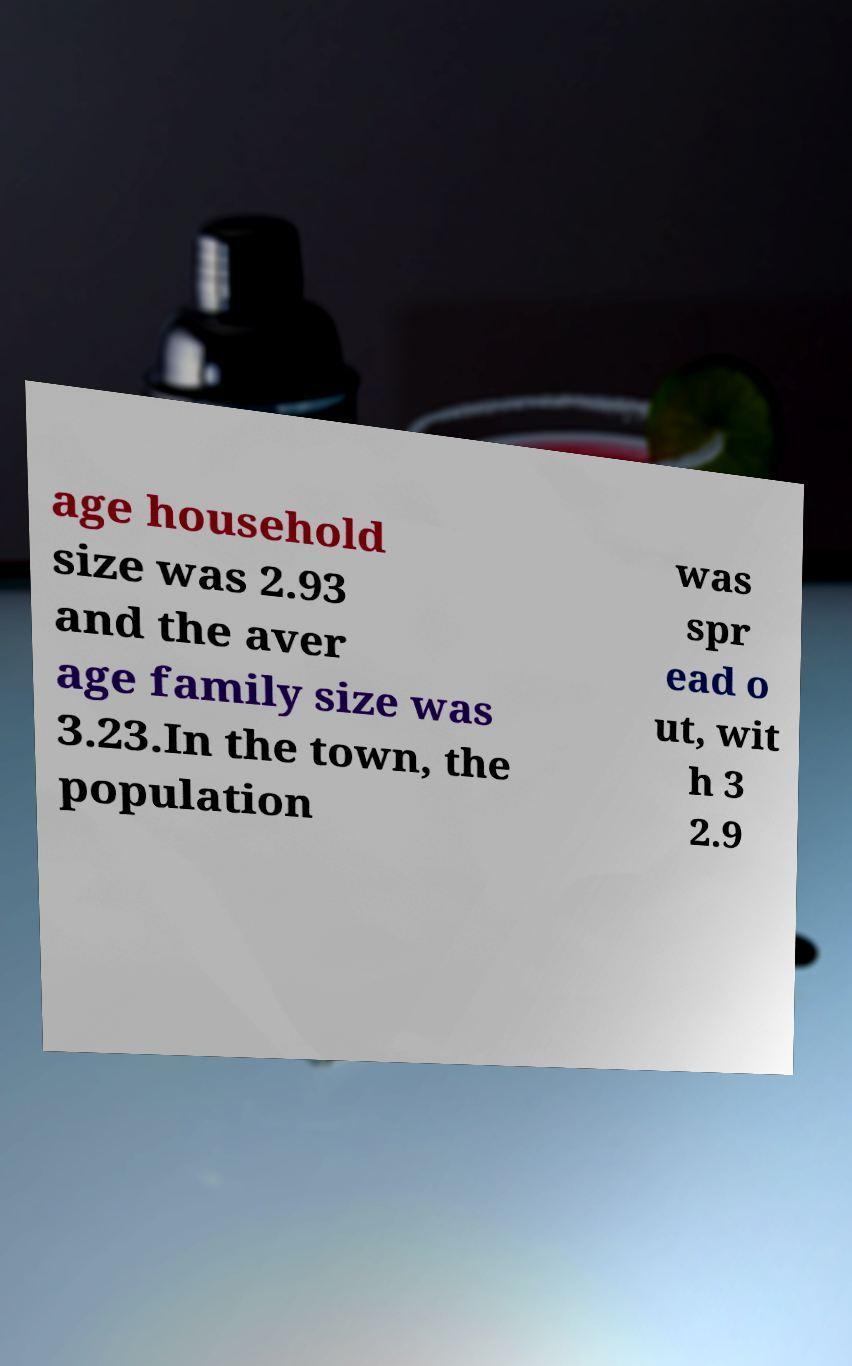Please read and relay the text visible in this image. What does it say? age household size was 2.93 and the aver age family size was 3.23.In the town, the population was spr ead o ut, wit h 3 2.9 